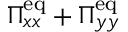Convert formula to latex. <formula><loc_0><loc_0><loc_500><loc_500>\Pi _ { x x } ^ { e q } + \Pi _ { y y } ^ { e q }</formula> 